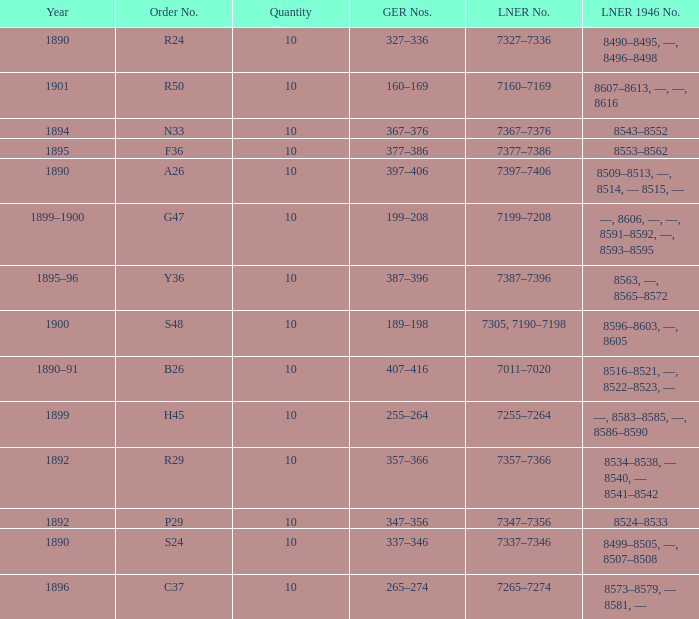What is order S24's LNER 1946 number? 8499–8505, —, 8507–8508. 